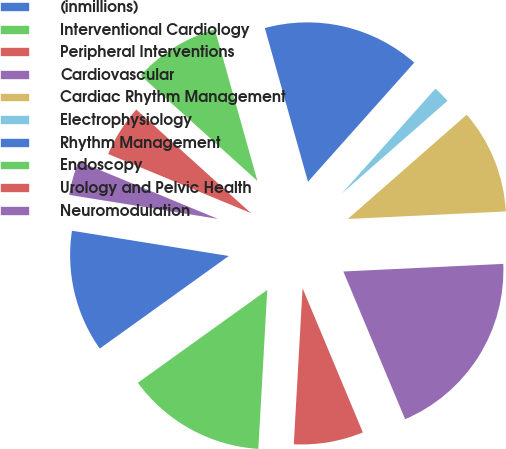Convert chart. <chart><loc_0><loc_0><loc_500><loc_500><pie_chart><fcel>(inmillions)<fcel>Interventional Cardiology<fcel>Peripheral Interventions<fcel>Cardiovascular<fcel>Cardiac Rhythm Management<fcel>Electrophysiology<fcel>Rhythm Management<fcel>Endoscopy<fcel>Urology and Pelvic Health<fcel>Neuromodulation<nl><fcel>12.45%<fcel>14.2%<fcel>7.2%<fcel>19.45%<fcel>10.7%<fcel>1.95%<fcel>15.95%<fcel>8.95%<fcel>5.45%<fcel>3.7%<nl></chart> 